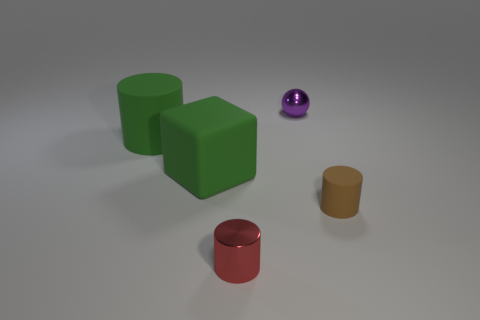Subtract 1 cylinders. How many cylinders are left? 2 Add 4 large cubes. How many objects exist? 9 Subtract all cubes. How many objects are left? 4 Subtract 0 brown blocks. How many objects are left? 5 Subtract all big red matte things. Subtract all matte objects. How many objects are left? 2 Add 5 matte cylinders. How many matte cylinders are left? 7 Add 2 tiny matte things. How many tiny matte things exist? 3 